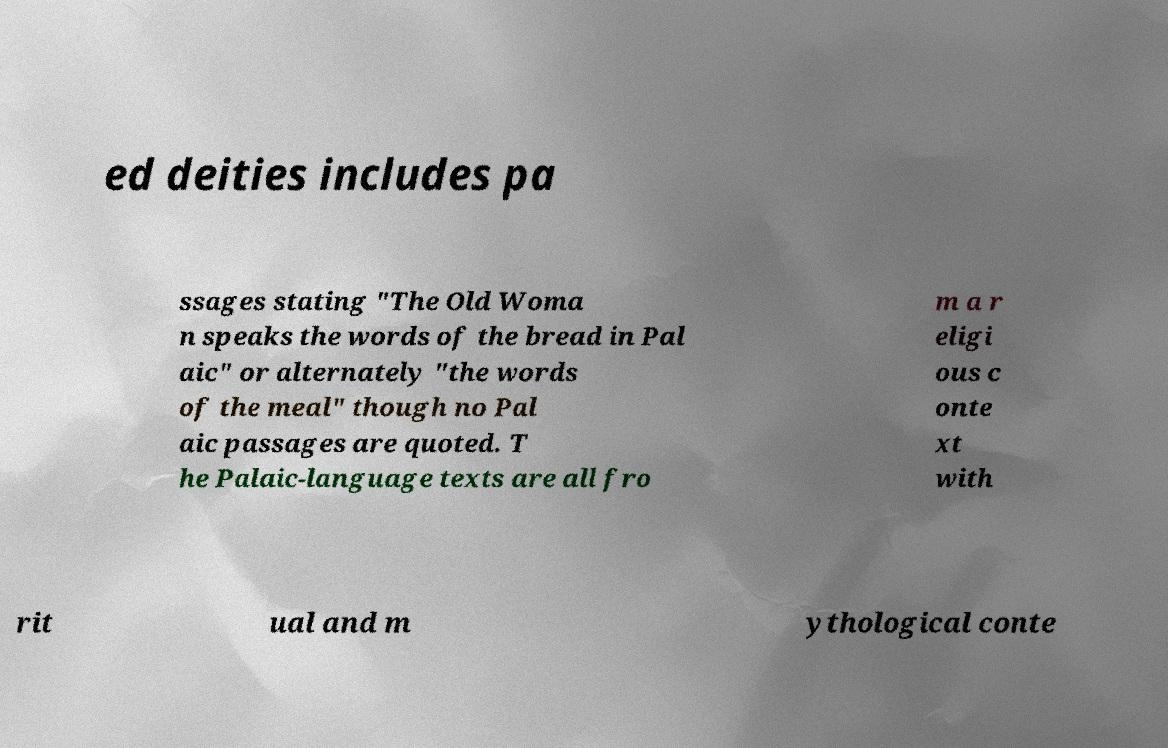For documentation purposes, I need the text within this image transcribed. Could you provide that? ed deities includes pa ssages stating "The Old Woma n speaks the words of the bread in Pal aic" or alternately "the words of the meal" though no Pal aic passages are quoted. T he Palaic-language texts are all fro m a r eligi ous c onte xt with rit ual and m ythological conte 